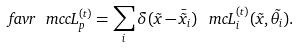Convert formula to latex. <formula><loc_0><loc_0><loc_500><loc_500>\ f a v r { \ m c c { L } ^ { ( t ) } _ { p } } = \sum _ { i } \delta ( \vec { x } - \bar { \vec { x } } _ { i } ) \, \ m c { L } ^ { ( t ) } _ { i } ( \vec { x } , \vec { \theta } _ { i } ) .</formula> 